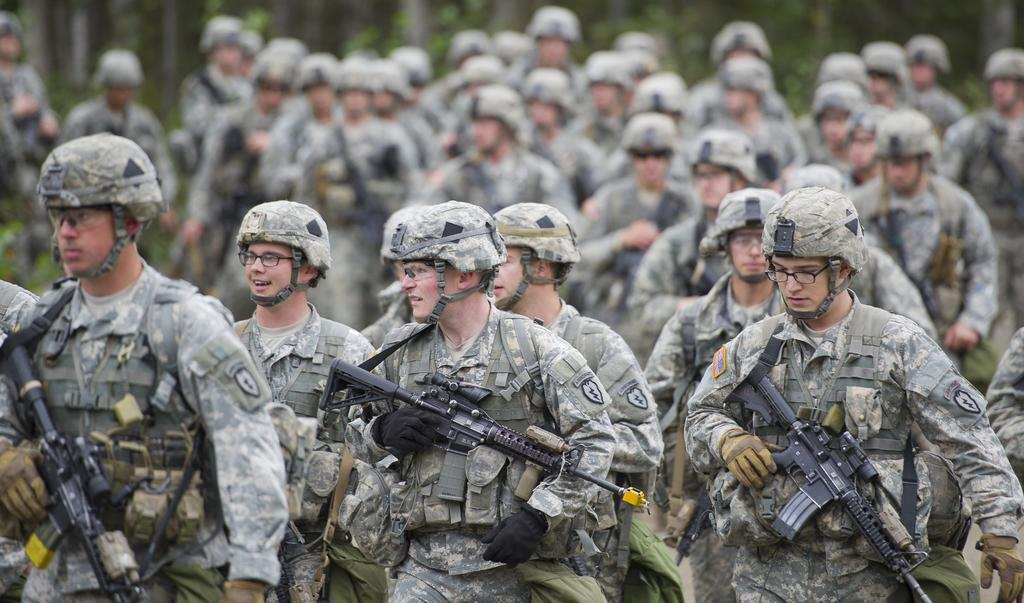What can be seen in the image in terms of people? There are groups of people in the image. What are the people holding in their hands? The people are holding weapons. What is the posture of the people in the image? The people are standing. What might be the occupation of the people based on their attire and equipment? They are likely to be soldiers, given their bulletproof jackets, helmets, and weapons. What type of sink can be seen in the image? There is no sink present in the image. 